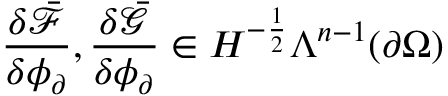Convert formula to latex. <formula><loc_0><loc_0><loc_500><loc_500>\frac { \delta \bar { \mathcal { F } } } { \delta \phi _ { \partial } } , \frac { \delta \bar { \mathcal { G } } } { \delta \phi _ { \partial } } \in H ^ { - \frac { 1 } { 2 } } \Lambda ^ { n - 1 } ( \partial \Omega )</formula> 